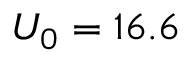Convert formula to latex. <formula><loc_0><loc_0><loc_500><loc_500>U _ { 0 } = 1 6 . 6</formula> 